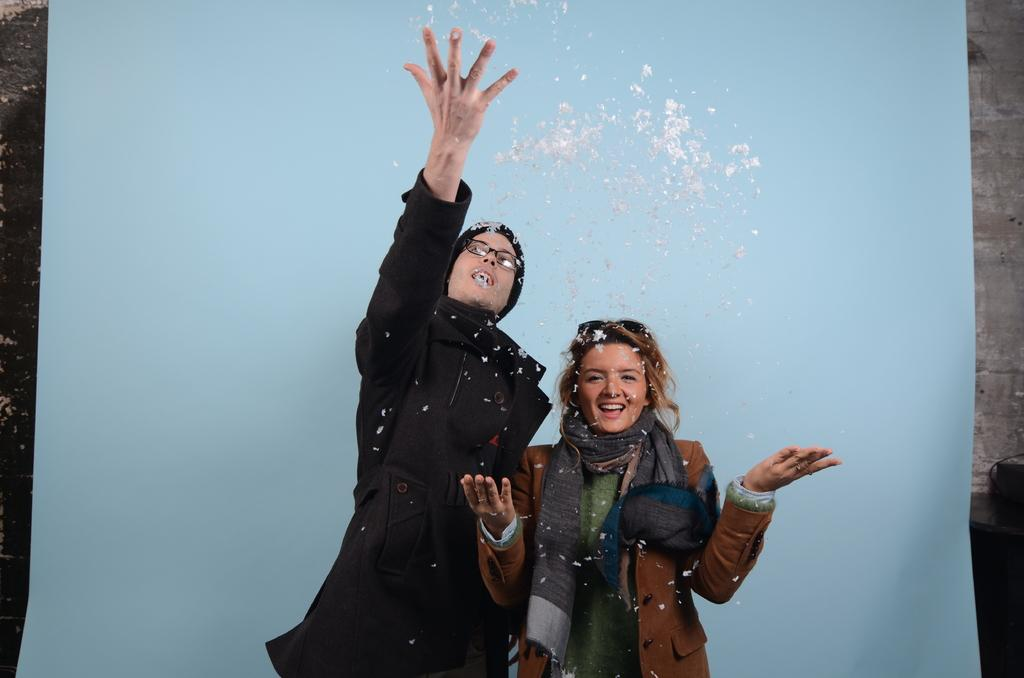How many people are in the image? There are two persons standing in the image. What is the object behind the persons that resembles a banner? There is an object behind the persons that looks like a banner. What can be seen in the background of the image? There is a wall visible in the background of the image. Can you tell me how many cakes are on the boat in the image? There is no boat or cakes present in the image. What type of stretch is the person performing in the image? There is no person performing a stretch in the image; the two persons are simply standing. 